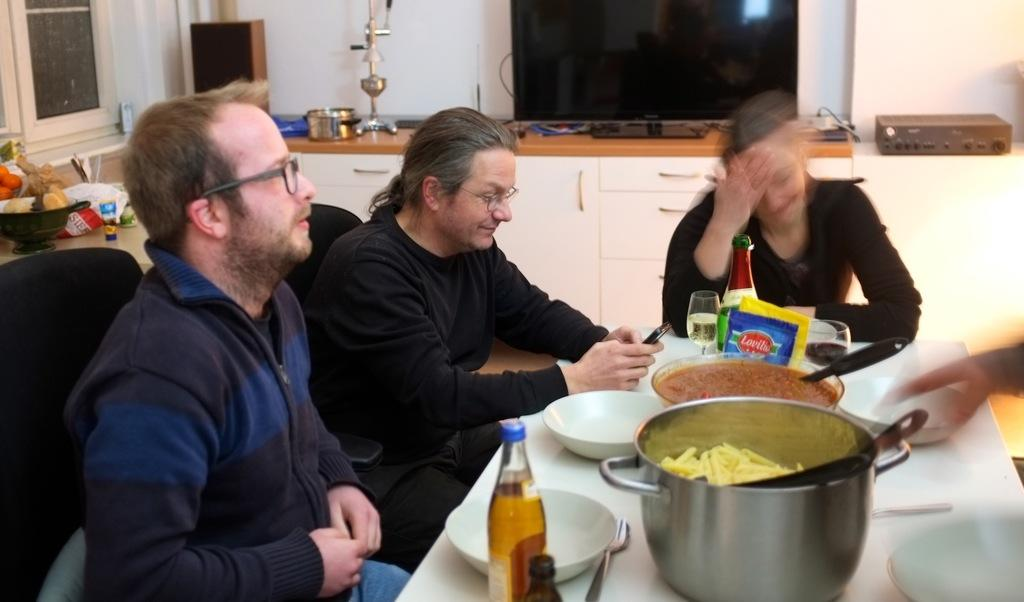What is the color of the wall in the image? The wall in the image is white. What can be seen on the wall in the image? There is a screen on the wall in the image. What type of furniture is present in the image? There are cupboards and chairs in the image. What is the main piece of furniture in the image? There is a table in the image. What items are on the table in the image? There are bowls, glasses, bottles, and dishes on the table in the image. Are there any people in the image? Yes, there are people sitting on chairs in the image. Can you tell me how many honeycombs are hanging from the ceiling in the image? There are no honeycombs or any reference to honey in the image. What type of trip is being taken by the people in the image? There is no indication of a trip or any travel-related activity in the image. 